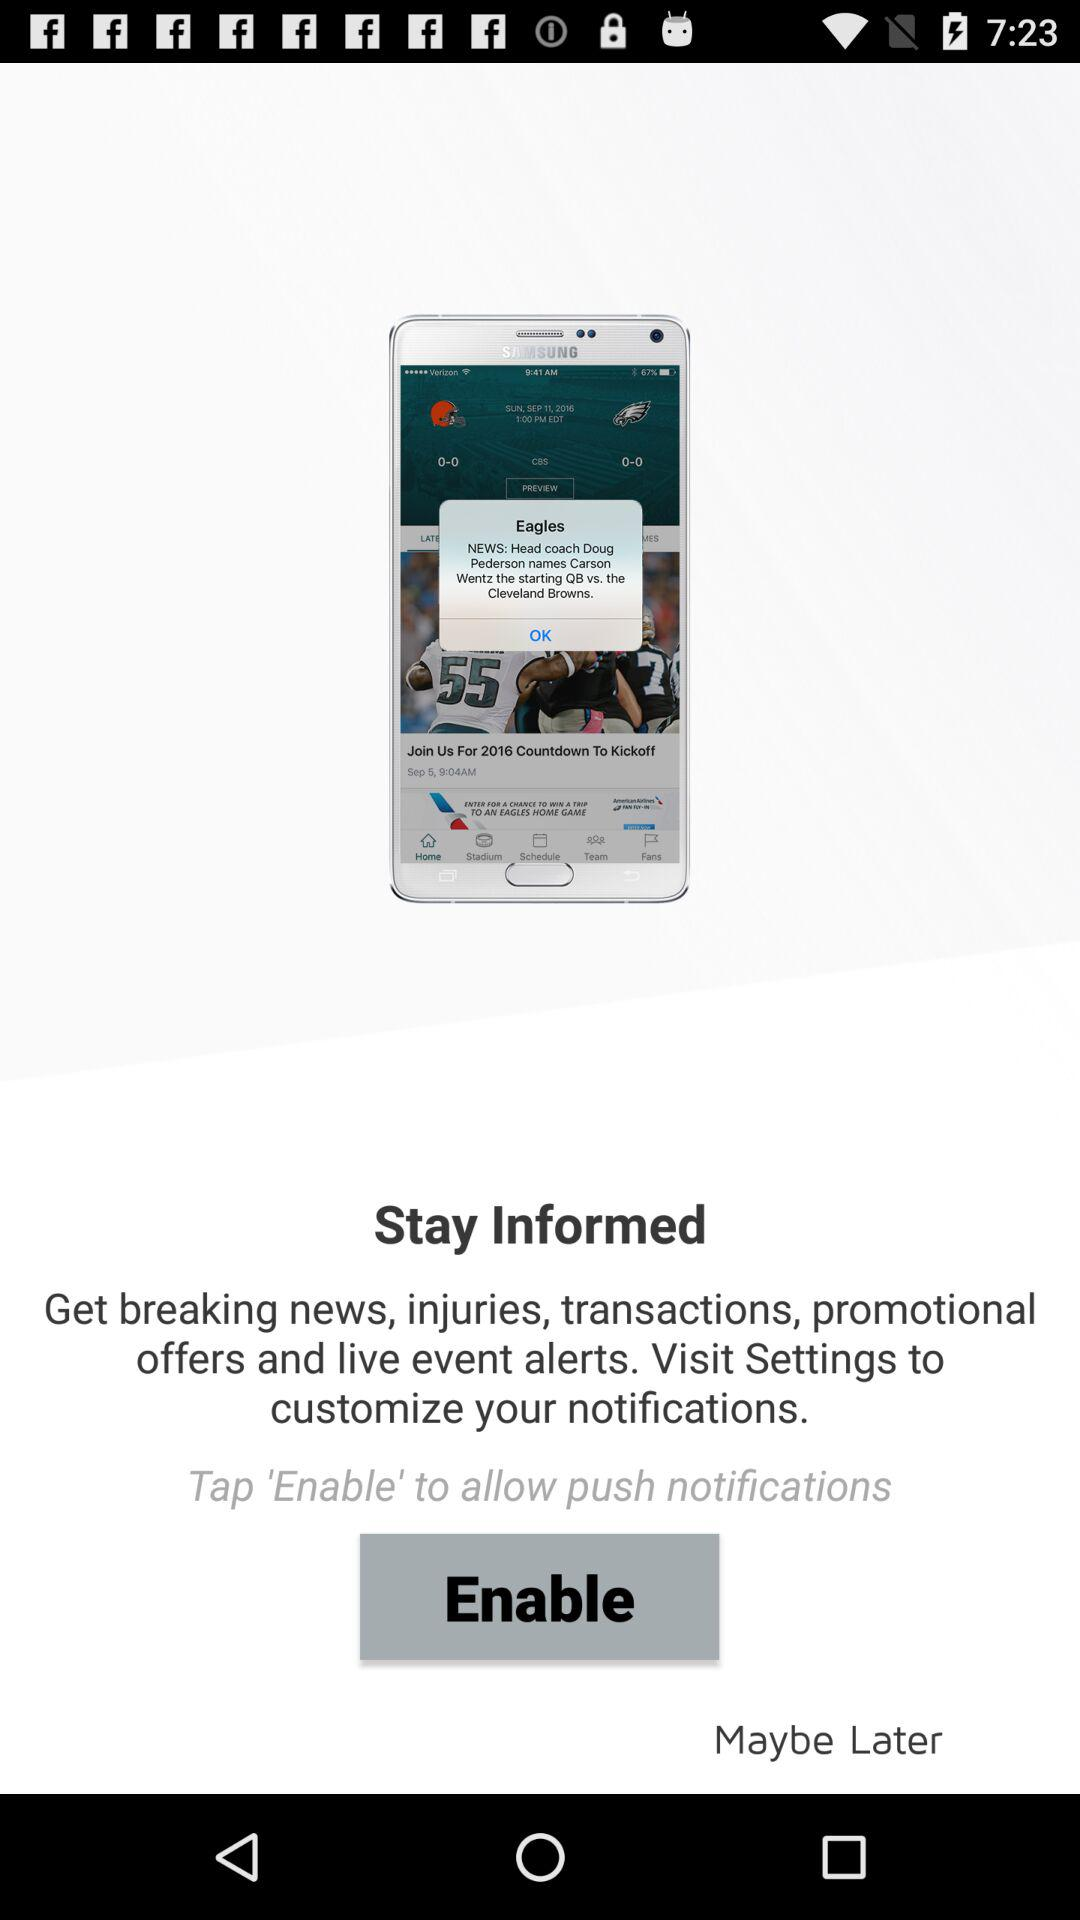What button do I tap to allow push notifications? To allow push notifications, tap "Enable" button. 